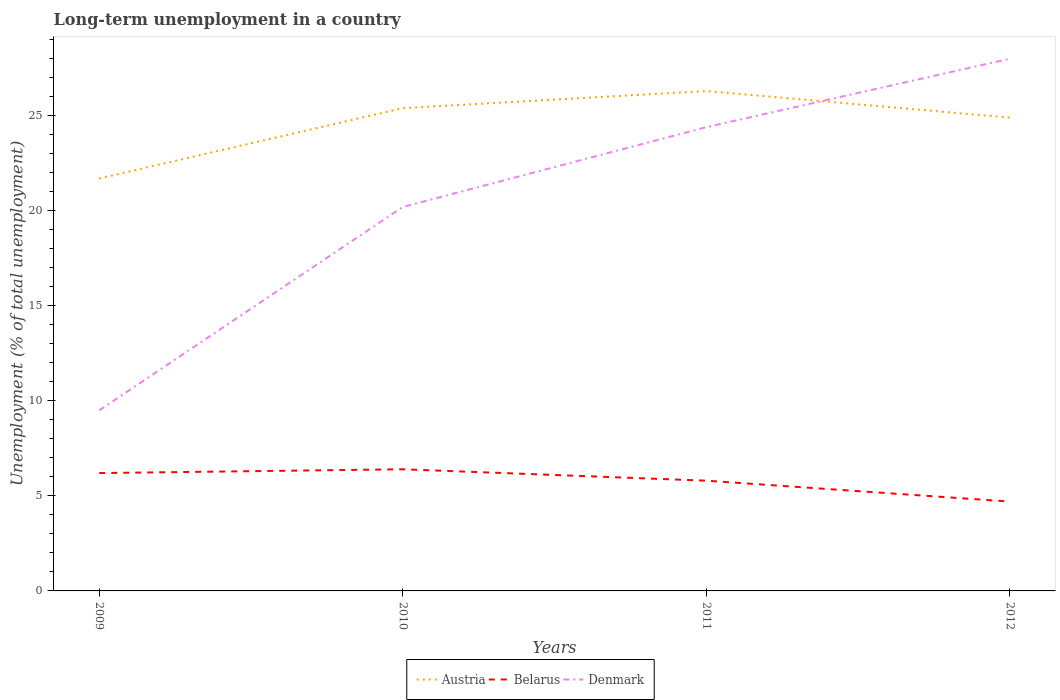Across all years, what is the maximum percentage of long-term unemployed population in Belarus?
Keep it short and to the point. 4.7. In which year was the percentage of long-term unemployed population in Belarus maximum?
Provide a succinct answer. 2012. What is the total percentage of long-term unemployed population in Austria in the graph?
Offer a terse response. 1.4. What is the difference between the highest and the second highest percentage of long-term unemployed population in Belarus?
Give a very brief answer. 1.7. How many years are there in the graph?
Provide a succinct answer. 4. Are the values on the major ticks of Y-axis written in scientific E-notation?
Provide a succinct answer. No. Does the graph contain grids?
Give a very brief answer. No. Where does the legend appear in the graph?
Offer a very short reply. Bottom center. How are the legend labels stacked?
Your answer should be compact. Horizontal. What is the title of the graph?
Your response must be concise. Long-term unemployment in a country. What is the label or title of the Y-axis?
Offer a terse response. Unemployment (% of total unemployment). What is the Unemployment (% of total unemployment) of Austria in 2009?
Your response must be concise. 21.7. What is the Unemployment (% of total unemployment) of Belarus in 2009?
Offer a very short reply. 6.2. What is the Unemployment (% of total unemployment) of Austria in 2010?
Your response must be concise. 25.4. What is the Unemployment (% of total unemployment) of Belarus in 2010?
Your answer should be compact. 6.4. What is the Unemployment (% of total unemployment) in Denmark in 2010?
Give a very brief answer. 20.2. What is the Unemployment (% of total unemployment) of Austria in 2011?
Offer a very short reply. 26.3. What is the Unemployment (% of total unemployment) in Belarus in 2011?
Offer a terse response. 5.8. What is the Unemployment (% of total unemployment) of Denmark in 2011?
Provide a short and direct response. 24.4. What is the Unemployment (% of total unemployment) of Austria in 2012?
Provide a succinct answer. 24.9. What is the Unemployment (% of total unemployment) of Belarus in 2012?
Provide a succinct answer. 4.7. Across all years, what is the maximum Unemployment (% of total unemployment) of Austria?
Provide a succinct answer. 26.3. Across all years, what is the maximum Unemployment (% of total unemployment) in Belarus?
Give a very brief answer. 6.4. Across all years, what is the minimum Unemployment (% of total unemployment) in Austria?
Offer a very short reply. 21.7. Across all years, what is the minimum Unemployment (% of total unemployment) of Belarus?
Keep it short and to the point. 4.7. Across all years, what is the minimum Unemployment (% of total unemployment) in Denmark?
Your answer should be compact. 9.5. What is the total Unemployment (% of total unemployment) of Austria in the graph?
Provide a succinct answer. 98.3. What is the total Unemployment (% of total unemployment) of Belarus in the graph?
Ensure brevity in your answer.  23.1. What is the total Unemployment (% of total unemployment) in Denmark in the graph?
Give a very brief answer. 82.1. What is the difference between the Unemployment (% of total unemployment) in Austria in 2009 and that in 2010?
Offer a very short reply. -3.7. What is the difference between the Unemployment (% of total unemployment) of Belarus in 2009 and that in 2010?
Your answer should be compact. -0.2. What is the difference between the Unemployment (% of total unemployment) of Denmark in 2009 and that in 2010?
Offer a terse response. -10.7. What is the difference between the Unemployment (% of total unemployment) of Denmark in 2009 and that in 2011?
Provide a succinct answer. -14.9. What is the difference between the Unemployment (% of total unemployment) in Belarus in 2009 and that in 2012?
Provide a succinct answer. 1.5. What is the difference between the Unemployment (% of total unemployment) in Denmark in 2009 and that in 2012?
Ensure brevity in your answer.  -18.5. What is the difference between the Unemployment (% of total unemployment) in Denmark in 2010 and that in 2011?
Keep it short and to the point. -4.2. What is the difference between the Unemployment (% of total unemployment) of Belarus in 2011 and that in 2012?
Keep it short and to the point. 1.1. What is the difference between the Unemployment (% of total unemployment) in Denmark in 2011 and that in 2012?
Give a very brief answer. -3.6. What is the difference between the Unemployment (% of total unemployment) of Austria in 2009 and the Unemployment (% of total unemployment) of Denmark in 2010?
Make the answer very short. 1.5. What is the difference between the Unemployment (% of total unemployment) of Belarus in 2009 and the Unemployment (% of total unemployment) of Denmark in 2011?
Provide a succinct answer. -18.2. What is the difference between the Unemployment (% of total unemployment) of Austria in 2009 and the Unemployment (% of total unemployment) of Belarus in 2012?
Your answer should be compact. 17. What is the difference between the Unemployment (% of total unemployment) of Austria in 2009 and the Unemployment (% of total unemployment) of Denmark in 2012?
Ensure brevity in your answer.  -6.3. What is the difference between the Unemployment (% of total unemployment) in Belarus in 2009 and the Unemployment (% of total unemployment) in Denmark in 2012?
Offer a terse response. -21.8. What is the difference between the Unemployment (% of total unemployment) of Austria in 2010 and the Unemployment (% of total unemployment) of Belarus in 2011?
Provide a succinct answer. 19.6. What is the difference between the Unemployment (% of total unemployment) in Belarus in 2010 and the Unemployment (% of total unemployment) in Denmark in 2011?
Offer a very short reply. -18. What is the difference between the Unemployment (% of total unemployment) in Austria in 2010 and the Unemployment (% of total unemployment) in Belarus in 2012?
Keep it short and to the point. 20.7. What is the difference between the Unemployment (% of total unemployment) in Austria in 2010 and the Unemployment (% of total unemployment) in Denmark in 2012?
Ensure brevity in your answer.  -2.6. What is the difference between the Unemployment (% of total unemployment) of Belarus in 2010 and the Unemployment (% of total unemployment) of Denmark in 2012?
Give a very brief answer. -21.6. What is the difference between the Unemployment (% of total unemployment) of Austria in 2011 and the Unemployment (% of total unemployment) of Belarus in 2012?
Keep it short and to the point. 21.6. What is the difference between the Unemployment (% of total unemployment) in Belarus in 2011 and the Unemployment (% of total unemployment) in Denmark in 2012?
Keep it short and to the point. -22.2. What is the average Unemployment (% of total unemployment) of Austria per year?
Provide a short and direct response. 24.57. What is the average Unemployment (% of total unemployment) of Belarus per year?
Provide a short and direct response. 5.78. What is the average Unemployment (% of total unemployment) in Denmark per year?
Offer a terse response. 20.52. In the year 2009, what is the difference between the Unemployment (% of total unemployment) in Belarus and Unemployment (% of total unemployment) in Denmark?
Offer a terse response. -3.3. In the year 2010, what is the difference between the Unemployment (% of total unemployment) of Austria and Unemployment (% of total unemployment) of Belarus?
Make the answer very short. 19. In the year 2010, what is the difference between the Unemployment (% of total unemployment) of Austria and Unemployment (% of total unemployment) of Denmark?
Your answer should be very brief. 5.2. In the year 2010, what is the difference between the Unemployment (% of total unemployment) in Belarus and Unemployment (% of total unemployment) in Denmark?
Your response must be concise. -13.8. In the year 2011, what is the difference between the Unemployment (% of total unemployment) in Austria and Unemployment (% of total unemployment) in Denmark?
Make the answer very short. 1.9. In the year 2011, what is the difference between the Unemployment (% of total unemployment) in Belarus and Unemployment (% of total unemployment) in Denmark?
Your answer should be compact. -18.6. In the year 2012, what is the difference between the Unemployment (% of total unemployment) of Austria and Unemployment (% of total unemployment) of Belarus?
Offer a very short reply. 20.2. In the year 2012, what is the difference between the Unemployment (% of total unemployment) in Belarus and Unemployment (% of total unemployment) in Denmark?
Ensure brevity in your answer.  -23.3. What is the ratio of the Unemployment (% of total unemployment) in Austria in 2009 to that in 2010?
Your response must be concise. 0.85. What is the ratio of the Unemployment (% of total unemployment) of Belarus in 2009 to that in 2010?
Make the answer very short. 0.97. What is the ratio of the Unemployment (% of total unemployment) in Denmark in 2009 to that in 2010?
Your answer should be compact. 0.47. What is the ratio of the Unemployment (% of total unemployment) of Austria in 2009 to that in 2011?
Your response must be concise. 0.83. What is the ratio of the Unemployment (% of total unemployment) in Belarus in 2009 to that in 2011?
Keep it short and to the point. 1.07. What is the ratio of the Unemployment (% of total unemployment) in Denmark in 2009 to that in 2011?
Provide a succinct answer. 0.39. What is the ratio of the Unemployment (% of total unemployment) in Austria in 2009 to that in 2012?
Offer a terse response. 0.87. What is the ratio of the Unemployment (% of total unemployment) of Belarus in 2009 to that in 2012?
Give a very brief answer. 1.32. What is the ratio of the Unemployment (% of total unemployment) in Denmark in 2009 to that in 2012?
Ensure brevity in your answer.  0.34. What is the ratio of the Unemployment (% of total unemployment) of Austria in 2010 to that in 2011?
Provide a succinct answer. 0.97. What is the ratio of the Unemployment (% of total unemployment) in Belarus in 2010 to that in 2011?
Offer a very short reply. 1.1. What is the ratio of the Unemployment (% of total unemployment) of Denmark in 2010 to that in 2011?
Make the answer very short. 0.83. What is the ratio of the Unemployment (% of total unemployment) in Austria in 2010 to that in 2012?
Give a very brief answer. 1.02. What is the ratio of the Unemployment (% of total unemployment) in Belarus in 2010 to that in 2012?
Keep it short and to the point. 1.36. What is the ratio of the Unemployment (% of total unemployment) of Denmark in 2010 to that in 2012?
Provide a succinct answer. 0.72. What is the ratio of the Unemployment (% of total unemployment) of Austria in 2011 to that in 2012?
Offer a very short reply. 1.06. What is the ratio of the Unemployment (% of total unemployment) in Belarus in 2011 to that in 2012?
Your response must be concise. 1.23. What is the ratio of the Unemployment (% of total unemployment) of Denmark in 2011 to that in 2012?
Keep it short and to the point. 0.87. What is the difference between the highest and the lowest Unemployment (% of total unemployment) in Austria?
Provide a succinct answer. 4.6. 